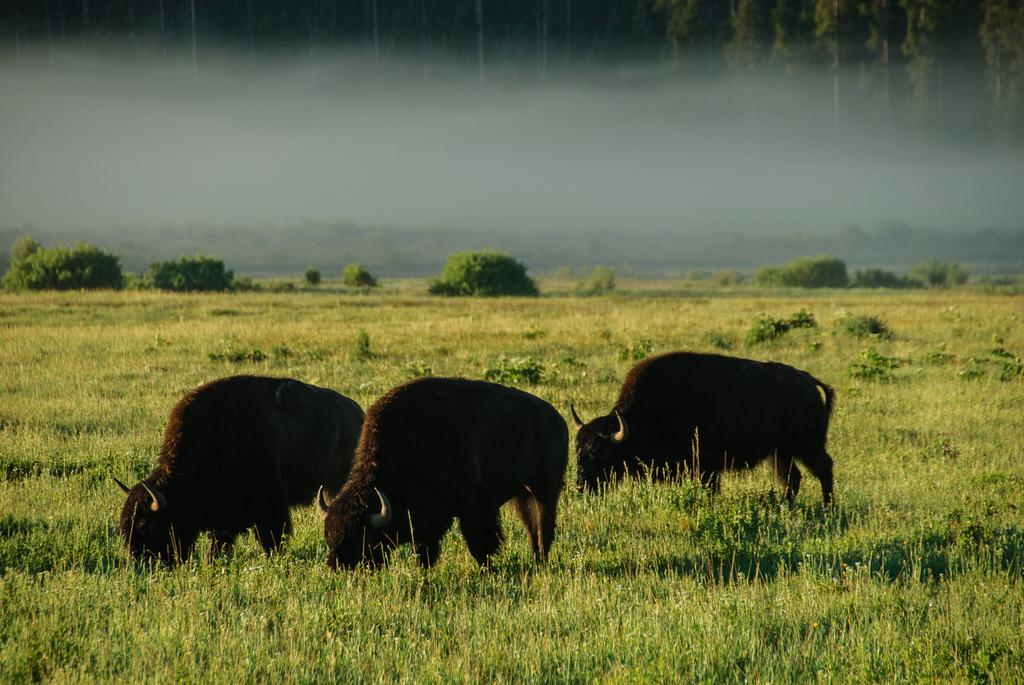What type of animals can be seen on the ground in the image? There are animals on the ground in the image, but their specific type is not mentioned in the facts. What type of vegetation is present in the image? There is grass and plants visible in the image. How would you describe the background of the image? The background of the image appears blurred. What can be observed in the blurred background? The blurred background contains greenery. What type of cheese is being used in the battle depicted in the image? There is no battle or cheese present in the image; it features animals on the ground with grass and plants in the background. Can you describe the flight of the animals in the image? There is no flight or flying animals present in the image; the animals are on the ground. 